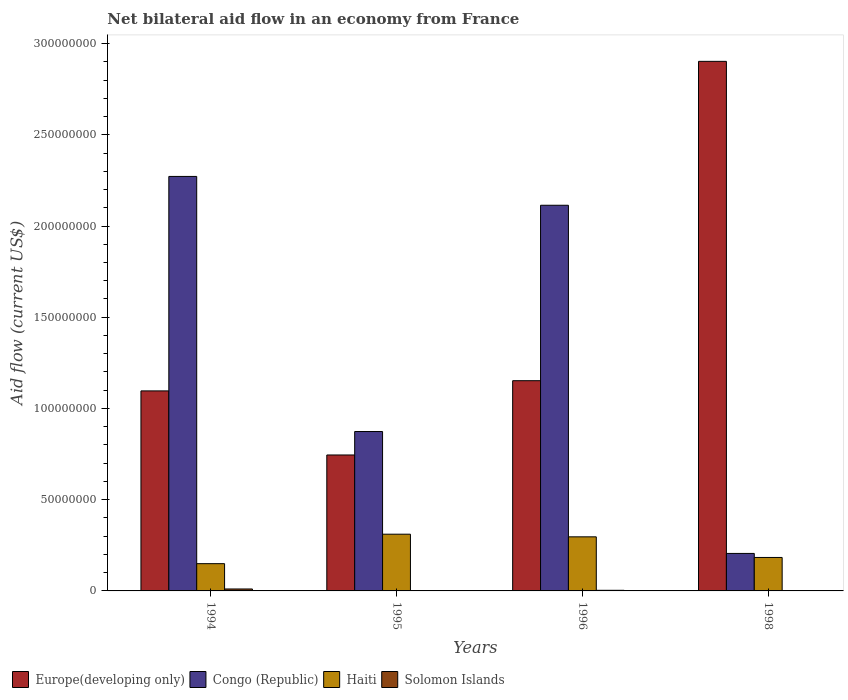How many different coloured bars are there?
Your response must be concise. 4. Are the number of bars per tick equal to the number of legend labels?
Your response must be concise. No. How many bars are there on the 3rd tick from the left?
Keep it short and to the point. 4. How many bars are there on the 3rd tick from the right?
Your response must be concise. 4. In how many cases, is the number of bars for a given year not equal to the number of legend labels?
Offer a very short reply. 1. What is the net bilateral aid flow in Congo (Republic) in 1994?
Your answer should be compact. 2.27e+08. Across all years, what is the maximum net bilateral aid flow in Solomon Islands?
Keep it short and to the point. 1.07e+06. Across all years, what is the minimum net bilateral aid flow in Haiti?
Your answer should be compact. 1.49e+07. What is the total net bilateral aid flow in Haiti in the graph?
Give a very brief answer. 9.40e+07. What is the difference between the net bilateral aid flow in Haiti in 1995 and that in 1998?
Offer a very short reply. 1.28e+07. What is the difference between the net bilateral aid flow in Haiti in 1996 and the net bilateral aid flow in Solomon Islands in 1994?
Your answer should be compact. 2.86e+07. What is the average net bilateral aid flow in Haiti per year?
Make the answer very short. 2.35e+07. In the year 1995, what is the difference between the net bilateral aid flow in Congo (Republic) and net bilateral aid flow in Europe(developing only)?
Provide a short and direct response. 1.28e+07. What is the ratio of the net bilateral aid flow in Europe(developing only) in 1995 to that in 1996?
Offer a very short reply. 0.65. Is the net bilateral aid flow in Haiti in 1994 less than that in 1998?
Offer a terse response. Yes. What is the difference between the highest and the second highest net bilateral aid flow in Congo (Republic)?
Make the answer very short. 1.58e+07. What is the difference between the highest and the lowest net bilateral aid flow in Congo (Republic)?
Offer a very short reply. 2.07e+08. Is the sum of the net bilateral aid flow in Europe(developing only) in 1994 and 1998 greater than the maximum net bilateral aid flow in Congo (Republic) across all years?
Your answer should be compact. Yes. How many bars are there?
Provide a short and direct response. 15. Are all the bars in the graph horizontal?
Offer a terse response. No. How many years are there in the graph?
Your answer should be very brief. 4. Does the graph contain any zero values?
Your answer should be very brief. Yes. Does the graph contain grids?
Your response must be concise. No. How many legend labels are there?
Make the answer very short. 4. How are the legend labels stacked?
Ensure brevity in your answer.  Horizontal. What is the title of the graph?
Give a very brief answer. Net bilateral aid flow in an economy from France. Does "High income" appear as one of the legend labels in the graph?
Ensure brevity in your answer.  No. What is the label or title of the X-axis?
Provide a short and direct response. Years. What is the Aid flow (current US$) of Europe(developing only) in 1994?
Your response must be concise. 1.10e+08. What is the Aid flow (current US$) in Congo (Republic) in 1994?
Your answer should be compact. 2.27e+08. What is the Aid flow (current US$) of Haiti in 1994?
Provide a short and direct response. 1.49e+07. What is the Aid flow (current US$) of Solomon Islands in 1994?
Provide a succinct answer. 1.07e+06. What is the Aid flow (current US$) of Europe(developing only) in 1995?
Make the answer very short. 7.45e+07. What is the Aid flow (current US$) in Congo (Republic) in 1995?
Ensure brevity in your answer.  8.74e+07. What is the Aid flow (current US$) of Haiti in 1995?
Your answer should be compact. 3.11e+07. What is the Aid flow (current US$) of Europe(developing only) in 1996?
Make the answer very short. 1.15e+08. What is the Aid flow (current US$) of Congo (Republic) in 1996?
Your answer should be very brief. 2.11e+08. What is the Aid flow (current US$) in Haiti in 1996?
Your answer should be compact. 2.96e+07. What is the Aid flow (current US$) of Solomon Islands in 1996?
Keep it short and to the point. 3.40e+05. What is the Aid flow (current US$) of Europe(developing only) in 1998?
Ensure brevity in your answer.  2.90e+08. What is the Aid flow (current US$) in Congo (Republic) in 1998?
Provide a succinct answer. 2.06e+07. What is the Aid flow (current US$) in Haiti in 1998?
Offer a terse response. 1.83e+07. What is the Aid flow (current US$) in Solomon Islands in 1998?
Make the answer very short. 0. Across all years, what is the maximum Aid flow (current US$) in Europe(developing only)?
Give a very brief answer. 2.90e+08. Across all years, what is the maximum Aid flow (current US$) of Congo (Republic)?
Keep it short and to the point. 2.27e+08. Across all years, what is the maximum Aid flow (current US$) in Haiti?
Provide a short and direct response. 3.11e+07. Across all years, what is the maximum Aid flow (current US$) in Solomon Islands?
Keep it short and to the point. 1.07e+06. Across all years, what is the minimum Aid flow (current US$) in Europe(developing only)?
Offer a very short reply. 7.45e+07. Across all years, what is the minimum Aid flow (current US$) in Congo (Republic)?
Give a very brief answer. 2.06e+07. Across all years, what is the minimum Aid flow (current US$) in Haiti?
Provide a short and direct response. 1.49e+07. Across all years, what is the minimum Aid flow (current US$) in Solomon Islands?
Offer a terse response. 0. What is the total Aid flow (current US$) in Europe(developing only) in the graph?
Your response must be concise. 5.90e+08. What is the total Aid flow (current US$) in Congo (Republic) in the graph?
Provide a short and direct response. 5.46e+08. What is the total Aid flow (current US$) of Haiti in the graph?
Give a very brief answer. 9.40e+07. What is the total Aid flow (current US$) of Solomon Islands in the graph?
Your response must be concise. 1.59e+06. What is the difference between the Aid flow (current US$) in Europe(developing only) in 1994 and that in 1995?
Your answer should be compact. 3.51e+07. What is the difference between the Aid flow (current US$) in Congo (Republic) in 1994 and that in 1995?
Offer a terse response. 1.40e+08. What is the difference between the Aid flow (current US$) of Haiti in 1994 and that in 1995?
Your response must be concise. -1.62e+07. What is the difference between the Aid flow (current US$) of Solomon Islands in 1994 and that in 1995?
Provide a short and direct response. 8.90e+05. What is the difference between the Aid flow (current US$) of Europe(developing only) in 1994 and that in 1996?
Offer a very short reply. -5.59e+06. What is the difference between the Aid flow (current US$) in Congo (Republic) in 1994 and that in 1996?
Ensure brevity in your answer.  1.58e+07. What is the difference between the Aid flow (current US$) of Haiti in 1994 and that in 1996?
Give a very brief answer. -1.47e+07. What is the difference between the Aid flow (current US$) in Solomon Islands in 1994 and that in 1996?
Ensure brevity in your answer.  7.30e+05. What is the difference between the Aid flow (current US$) of Europe(developing only) in 1994 and that in 1998?
Keep it short and to the point. -1.81e+08. What is the difference between the Aid flow (current US$) of Congo (Republic) in 1994 and that in 1998?
Your answer should be compact. 2.07e+08. What is the difference between the Aid flow (current US$) of Haiti in 1994 and that in 1998?
Give a very brief answer. -3.40e+06. What is the difference between the Aid flow (current US$) in Europe(developing only) in 1995 and that in 1996?
Your answer should be compact. -4.07e+07. What is the difference between the Aid flow (current US$) of Congo (Republic) in 1995 and that in 1996?
Provide a short and direct response. -1.24e+08. What is the difference between the Aid flow (current US$) in Haiti in 1995 and that in 1996?
Provide a short and direct response. 1.45e+06. What is the difference between the Aid flow (current US$) in Europe(developing only) in 1995 and that in 1998?
Offer a very short reply. -2.16e+08. What is the difference between the Aid flow (current US$) of Congo (Republic) in 1995 and that in 1998?
Offer a terse response. 6.68e+07. What is the difference between the Aid flow (current US$) of Haiti in 1995 and that in 1998?
Keep it short and to the point. 1.28e+07. What is the difference between the Aid flow (current US$) in Europe(developing only) in 1996 and that in 1998?
Your response must be concise. -1.75e+08. What is the difference between the Aid flow (current US$) in Congo (Republic) in 1996 and that in 1998?
Offer a very short reply. 1.91e+08. What is the difference between the Aid flow (current US$) of Haiti in 1996 and that in 1998?
Keep it short and to the point. 1.13e+07. What is the difference between the Aid flow (current US$) of Europe(developing only) in 1994 and the Aid flow (current US$) of Congo (Republic) in 1995?
Make the answer very short. 2.23e+07. What is the difference between the Aid flow (current US$) of Europe(developing only) in 1994 and the Aid flow (current US$) of Haiti in 1995?
Give a very brief answer. 7.85e+07. What is the difference between the Aid flow (current US$) of Europe(developing only) in 1994 and the Aid flow (current US$) of Solomon Islands in 1995?
Ensure brevity in your answer.  1.09e+08. What is the difference between the Aid flow (current US$) in Congo (Republic) in 1994 and the Aid flow (current US$) in Haiti in 1995?
Your answer should be compact. 1.96e+08. What is the difference between the Aid flow (current US$) in Congo (Republic) in 1994 and the Aid flow (current US$) in Solomon Islands in 1995?
Give a very brief answer. 2.27e+08. What is the difference between the Aid flow (current US$) in Haiti in 1994 and the Aid flow (current US$) in Solomon Islands in 1995?
Make the answer very short. 1.48e+07. What is the difference between the Aid flow (current US$) of Europe(developing only) in 1994 and the Aid flow (current US$) of Congo (Republic) in 1996?
Ensure brevity in your answer.  -1.02e+08. What is the difference between the Aid flow (current US$) in Europe(developing only) in 1994 and the Aid flow (current US$) in Haiti in 1996?
Offer a terse response. 8.00e+07. What is the difference between the Aid flow (current US$) in Europe(developing only) in 1994 and the Aid flow (current US$) in Solomon Islands in 1996?
Make the answer very short. 1.09e+08. What is the difference between the Aid flow (current US$) in Congo (Republic) in 1994 and the Aid flow (current US$) in Haiti in 1996?
Offer a very short reply. 1.98e+08. What is the difference between the Aid flow (current US$) in Congo (Republic) in 1994 and the Aid flow (current US$) in Solomon Islands in 1996?
Your answer should be very brief. 2.27e+08. What is the difference between the Aid flow (current US$) of Haiti in 1994 and the Aid flow (current US$) of Solomon Islands in 1996?
Give a very brief answer. 1.46e+07. What is the difference between the Aid flow (current US$) in Europe(developing only) in 1994 and the Aid flow (current US$) in Congo (Republic) in 1998?
Offer a terse response. 8.91e+07. What is the difference between the Aid flow (current US$) of Europe(developing only) in 1994 and the Aid flow (current US$) of Haiti in 1998?
Your answer should be compact. 9.13e+07. What is the difference between the Aid flow (current US$) of Congo (Republic) in 1994 and the Aid flow (current US$) of Haiti in 1998?
Your response must be concise. 2.09e+08. What is the difference between the Aid flow (current US$) of Europe(developing only) in 1995 and the Aid flow (current US$) of Congo (Republic) in 1996?
Your answer should be very brief. -1.37e+08. What is the difference between the Aid flow (current US$) in Europe(developing only) in 1995 and the Aid flow (current US$) in Haiti in 1996?
Give a very brief answer. 4.49e+07. What is the difference between the Aid flow (current US$) in Europe(developing only) in 1995 and the Aid flow (current US$) in Solomon Islands in 1996?
Keep it short and to the point. 7.42e+07. What is the difference between the Aid flow (current US$) of Congo (Republic) in 1995 and the Aid flow (current US$) of Haiti in 1996?
Ensure brevity in your answer.  5.77e+07. What is the difference between the Aid flow (current US$) in Congo (Republic) in 1995 and the Aid flow (current US$) in Solomon Islands in 1996?
Keep it short and to the point. 8.70e+07. What is the difference between the Aid flow (current US$) in Haiti in 1995 and the Aid flow (current US$) in Solomon Islands in 1996?
Provide a short and direct response. 3.08e+07. What is the difference between the Aid flow (current US$) of Europe(developing only) in 1995 and the Aid flow (current US$) of Congo (Republic) in 1998?
Offer a very short reply. 5.40e+07. What is the difference between the Aid flow (current US$) of Europe(developing only) in 1995 and the Aid flow (current US$) of Haiti in 1998?
Your answer should be very brief. 5.62e+07. What is the difference between the Aid flow (current US$) in Congo (Republic) in 1995 and the Aid flow (current US$) in Haiti in 1998?
Offer a terse response. 6.90e+07. What is the difference between the Aid flow (current US$) of Europe(developing only) in 1996 and the Aid flow (current US$) of Congo (Republic) in 1998?
Ensure brevity in your answer.  9.47e+07. What is the difference between the Aid flow (current US$) in Europe(developing only) in 1996 and the Aid flow (current US$) in Haiti in 1998?
Your answer should be very brief. 9.69e+07. What is the difference between the Aid flow (current US$) in Congo (Republic) in 1996 and the Aid flow (current US$) in Haiti in 1998?
Provide a short and direct response. 1.93e+08. What is the average Aid flow (current US$) of Europe(developing only) per year?
Provide a short and direct response. 1.47e+08. What is the average Aid flow (current US$) of Congo (Republic) per year?
Keep it short and to the point. 1.37e+08. What is the average Aid flow (current US$) of Haiti per year?
Your answer should be compact. 2.35e+07. What is the average Aid flow (current US$) in Solomon Islands per year?
Offer a terse response. 3.98e+05. In the year 1994, what is the difference between the Aid flow (current US$) of Europe(developing only) and Aid flow (current US$) of Congo (Republic)?
Give a very brief answer. -1.18e+08. In the year 1994, what is the difference between the Aid flow (current US$) in Europe(developing only) and Aid flow (current US$) in Haiti?
Provide a short and direct response. 9.47e+07. In the year 1994, what is the difference between the Aid flow (current US$) in Europe(developing only) and Aid flow (current US$) in Solomon Islands?
Ensure brevity in your answer.  1.09e+08. In the year 1994, what is the difference between the Aid flow (current US$) in Congo (Republic) and Aid flow (current US$) in Haiti?
Your answer should be compact. 2.12e+08. In the year 1994, what is the difference between the Aid flow (current US$) of Congo (Republic) and Aid flow (current US$) of Solomon Islands?
Offer a very short reply. 2.26e+08. In the year 1994, what is the difference between the Aid flow (current US$) in Haiti and Aid flow (current US$) in Solomon Islands?
Your answer should be compact. 1.39e+07. In the year 1995, what is the difference between the Aid flow (current US$) in Europe(developing only) and Aid flow (current US$) in Congo (Republic)?
Offer a terse response. -1.28e+07. In the year 1995, what is the difference between the Aid flow (current US$) in Europe(developing only) and Aid flow (current US$) in Haiti?
Give a very brief answer. 4.34e+07. In the year 1995, what is the difference between the Aid flow (current US$) in Europe(developing only) and Aid flow (current US$) in Solomon Islands?
Keep it short and to the point. 7.43e+07. In the year 1995, what is the difference between the Aid flow (current US$) in Congo (Republic) and Aid flow (current US$) in Haiti?
Your response must be concise. 5.63e+07. In the year 1995, what is the difference between the Aid flow (current US$) of Congo (Republic) and Aid flow (current US$) of Solomon Islands?
Provide a succinct answer. 8.72e+07. In the year 1995, what is the difference between the Aid flow (current US$) of Haiti and Aid flow (current US$) of Solomon Islands?
Offer a very short reply. 3.09e+07. In the year 1996, what is the difference between the Aid flow (current US$) in Europe(developing only) and Aid flow (current US$) in Congo (Republic)?
Offer a very short reply. -9.62e+07. In the year 1996, what is the difference between the Aid flow (current US$) of Europe(developing only) and Aid flow (current US$) of Haiti?
Ensure brevity in your answer.  8.56e+07. In the year 1996, what is the difference between the Aid flow (current US$) of Europe(developing only) and Aid flow (current US$) of Solomon Islands?
Provide a short and direct response. 1.15e+08. In the year 1996, what is the difference between the Aid flow (current US$) in Congo (Republic) and Aid flow (current US$) in Haiti?
Your answer should be very brief. 1.82e+08. In the year 1996, what is the difference between the Aid flow (current US$) in Congo (Republic) and Aid flow (current US$) in Solomon Islands?
Make the answer very short. 2.11e+08. In the year 1996, what is the difference between the Aid flow (current US$) in Haiti and Aid flow (current US$) in Solomon Islands?
Your response must be concise. 2.93e+07. In the year 1998, what is the difference between the Aid flow (current US$) in Europe(developing only) and Aid flow (current US$) in Congo (Republic)?
Ensure brevity in your answer.  2.70e+08. In the year 1998, what is the difference between the Aid flow (current US$) in Europe(developing only) and Aid flow (current US$) in Haiti?
Keep it short and to the point. 2.72e+08. In the year 1998, what is the difference between the Aid flow (current US$) in Congo (Republic) and Aid flow (current US$) in Haiti?
Your response must be concise. 2.21e+06. What is the ratio of the Aid flow (current US$) in Europe(developing only) in 1994 to that in 1995?
Offer a very short reply. 1.47. What is the ratio of the Aid flow (current US$) of Congo (Republic) in 1994 to that in 1995?
Provide a short and direct response. 2.6. What is the ratio of the Aid flow (current US$) of Haiti in 1994 to that in 1995?
Give a very brief answer. 0.48. What is the ratio of the Aid flow (current US$) in Solomon Islands in 1994 to that in 1995?
Make the answer very short. 5.94. What is the ratio of the Aid flow (current US$) of Europe(developing only) in 1994 to that in 1996?
Give a very brief answer. 0.95. What is the ratio of the Aid flow (current US$) of Congo (Republic) in 1994 to that in 1996?
Provide a short and direct response. 1.07. What is the ratio of the Aid flow (current US$) of Haiti in 1994 to that in 1996?
Give a very brief answer. 0.5. What is the ratio of the Aid flow (current US$) in Solomon Islands in 1994 to that in 1996?
Make the answer very short. 3.15. What is the ratio of the Aid flow (current US$) in Europe(developing only) in 1994 to that in 1998?
Your answer should be compact. 0.38. What is the ratio of the Aid flow (current US$) of Congo (Republic) in 1994 to that in 1998?
Keep it short and to the point. 11.05. What is the ratio of the Aid flow (current US$) of Haiti in 1994 to that in 1998?
Your answer should be compact. 0.81. What is the ratio of the Aid flow (current US$) of Europe(developing only) in 1995 to that in 1996?
Keep it short and to the point. 0.65. What is the ratio of the Aid flow (current US$) in Congo (Republic) in 1995 to that in 1996?
Your answer should be very brief. 0.41. What is the ratio of the Aid flow (current US$) of Haiti in 1995 to that in 1996?
Your answer should be very brief. 1.05. What is the ratio of the Aid flow (current US$) of Solomon Islands in 1995 to that in 1996?
Give a very brief answer. 0.53. What is the ratio of the Aid flow (current US$) of Europe(developing only) in 1995 to that in 1998?
Ensure brevity in your answer.  0.26. What is the ratio of the Aid flow (current US$) in Congo (Republic) in 1995 to that in 1998?
Give a very brief answer. 4.25. What is the ratio of the Aid flow (current US$) of Haiti in 1995 to that in 1998?
Your answer should be compact. 1.7. What is the ratio of the Aid flow (current US$) in Europe(developing only) in 1996 to that in 1998?
Offer a terse response. 0.4. What is the ratio of the Aid flow (current US$) in Congo (Republic) in 1996 to that in 1998?
Your answer should be very brief. 10.29. What is the ratio of the Aid flow (current US$) of Haiti in 1996 to that in 1998?
Provide a succinct answer. 1.62. What is the difference between the highest and the second highest Aid flow (current US$) of Europe(developing only)?
Offer a very short reply. 1.75e+08. What is the difference between the highest and the second highest Aid flow (current US$) in Congo (Republic)?
Give a very brief answer. 1.58e+07. What is the difference between the highest and the second highest Aid flow (current US$) of Haiti?
Your answer should be compact. 1.45e+06. What is the difference between the highest and the second highest Aid flow (current US$) in Solomon Islands?
Make the answer very short. 7.30e+05. What is the difference between the highest and the lowest Aid flow (current US$) in Europe(developing only)?
Give a very brief answer. 2.16e+08. What is the difference between the highest and the lowest Aid flow (current US$) in Congo (Republic)?
Offer a very short reply. 2.07e+08. What is the difference between the highest and the lowest Aid flow (current US$) of Haiti?
Offer a terse response. 1.62e+07. What is the difference between the highest and the lowest Aid flow (current US$) of Solomon Islands?
Keep it short and to the point. 1.07e+06. 